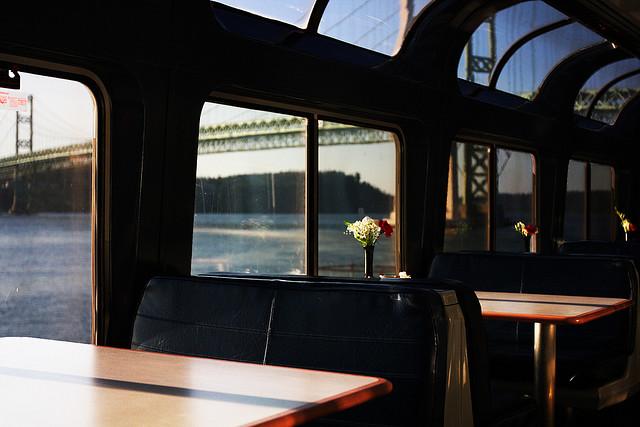What is in front of the train?
Be succinct. Bridge. Does the water appear calm or rough?
Concise answer only. Calm. At what level was this photo taken?
Short answer required. Sea level. What bridge can be seen in the distance?
Answer briefly. Golden gate. Where is this taken?
Short answer required. Boat. How many planes?
Short answer required. 0. What color are the flowers?
Write a very short answer. White and red. 